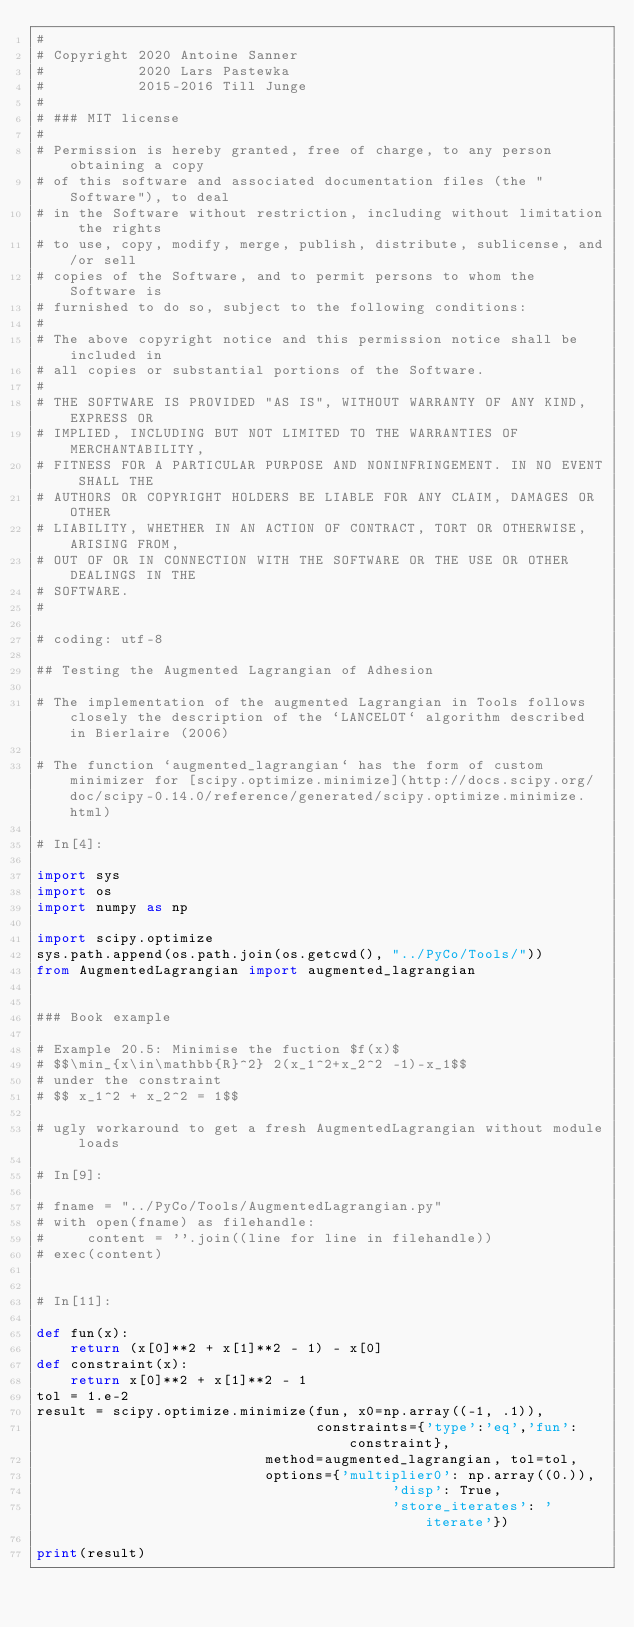Convert code to text. <code><loc_0><loc_0><loc_500><loc_500><_Python_>#
# Copyright 2020 Antoine Sanner
#           2020 Lars Pastewka
#           2015-2016 Till Junge
#
# ### MIT license
#
# Permission is hereby granted, free of charge, to any person obtaining a copy
# of this software and associated documentation files (the "Software"), to deal
# in the Software without restriction, including without limitation the rights
# to use, copy, modify, merge, publish, distribute, sublicense, and/or sell
# copies of the Software, and to permit persons to whom the Software is
# furnished to do so, subject to the following conditions:
#
# The above copyright notice and this permission notice shall be included in
# all copies or substantial portions of the Software.
#
# THE SOFTWARE IS PROVIDED "AS IS", WITHOUT WARRANTY OF ANY KIND, EXPRESS OR
# IMPLIED, INCLUDING BUT NOT LIMITED TO THE WARRANTIES OF MERCHANTABILITY,
# FITNESS FOR A PARTICULAR PURPOSE AND NONINFRINGEMENT. IN NO EVENT SHALL THE
# AUTHORS OR COPYRIGHT HOLDERS BE LIABLE FOR ANY CLAIM, DAMAGES OR OTHER
# LIABILITY, WHETHER IN AN ACTION OF CONTRACT, TORT OR OTHERWISE, ARISING FROM,
# OUT OF OR IN CONNECTION WITH THE SOFTWARE OR THE USE OR OTHER DEALINGS IN THE
# SOFTWARE.
#

# coding: utf-8

## Testing the Augmented Lagrangian of Adhesion

# The implementation of the augmented Lagrangian in Tools follows closely the description of the `LANCELOT` algorithm described in Bierlaire (2006)

# The function `augmented_lagrangian` has the form of custom minimizer for [scipy.optimize.minimize](http://docs.scipy.org/doc/scipy-0.14.0/reference/generated/scipy.optimize.minimize.html)

# In[4]:

import sys
import os
import numpy as np

import scipy.optimize
sys.path.append(os.path.join(os.getcwd(), "../PyCo/Tools/"))
from AugmentedLagrangian import augmented_lagrangian


### Book example

# Example 20.5: Minimise the fuction $f(x)$
# $$\min_{x\in\mathbb{R}^2} 2(x_1^2+x_2^2 -1)-x_1$$
# under the constraint
# $$ x_1^2 + x_2^2 = 1$$

# ugly workaround to get a fresh AugmentedLagrangian without module loads

# In[9]:

# fname = "../PyCo/Tools/AugmentedLagrangian.py"
# with open(fname) as filehandle:
#     content = ''.join((line for line in filehandle))
# exec(content)


# In[11]:

def fun(x):
    return (x[0]**2 + x[1]**2 - 1) - x[0]
def constraint(x):
    return x[0]**2 + x[1]**2 - 1
tol = 1.e-2
result = scipy.optimize.minimize(fun, x0=np.array((-1, .1)),
       	                         constraints={'type':'eq','fun':constraint},
	                         method=augmented_lagrangian, tol=tol,
	                         options={'multiplier0': np.array((0.)),
                                          'disp': True,
                                          'store_iterates': 'iterate'})

print(result)

</code> 